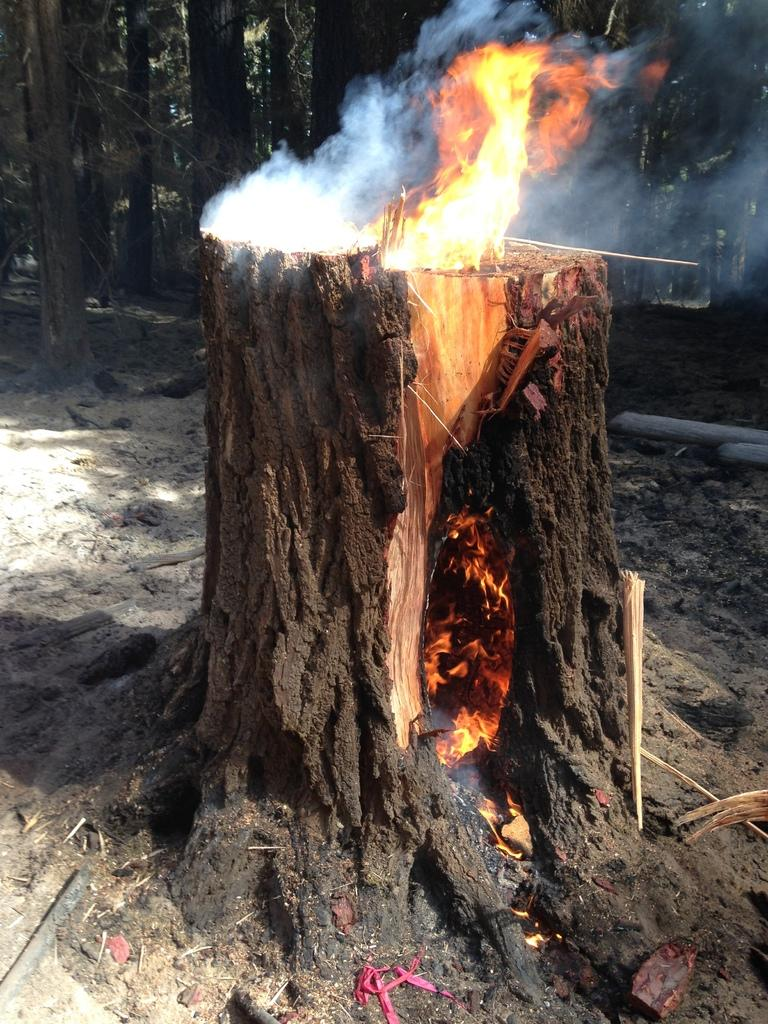What is happening in the foreground of the image? There is fire in a tree in the foreground of the image. What can be seen in the background of the image? There is a group of trees in the background of the image. What type of skirt is being worn by the secretary in the image? There is no secretary or skirt present in the image; it features fire in a tree and a group of trees in the background. 